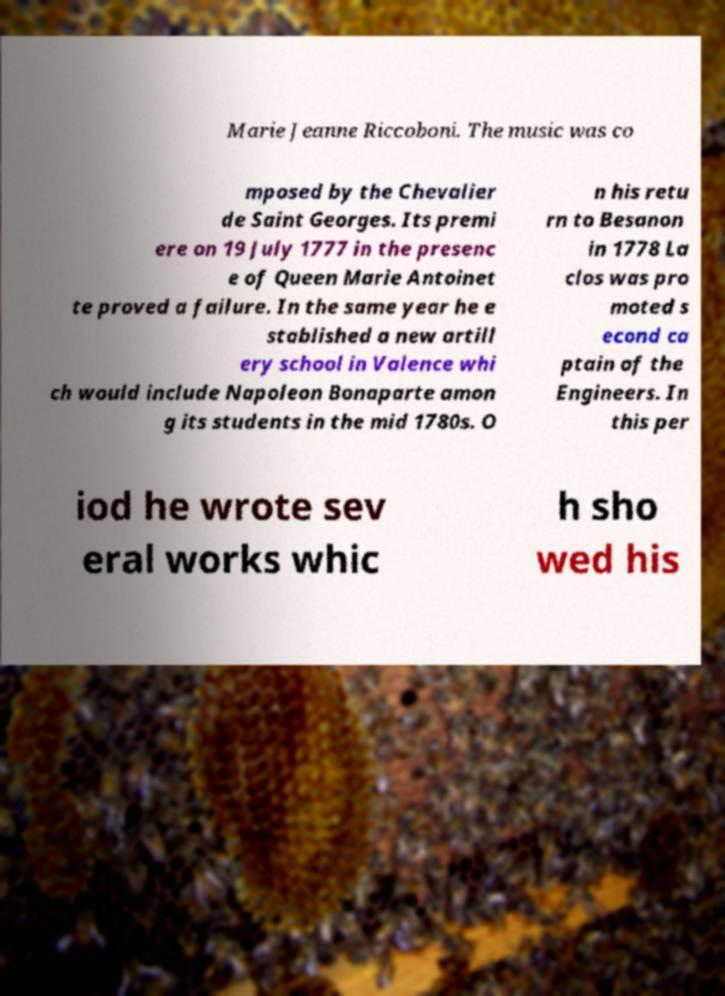Can you accurately transcribe the text from the provided image for me? Marie Jeanne Riccoboni. The music was co mposed by the Chevalier de Saint Georges. Its premi ere on 19 July 1777 in the presenc e of Queen Marie Antoinet te proved a failure. In the same year he e stablished a new artill ery school in Valence whi ch would include Napoleon Bonaparte amon g its students in the mid 1780s. O n his retu rn to Besanon in 1778 La clos was pro moted s econd ca ptain of the Engineers. In this per iod he wrote sev eral works whic h sho wed his 